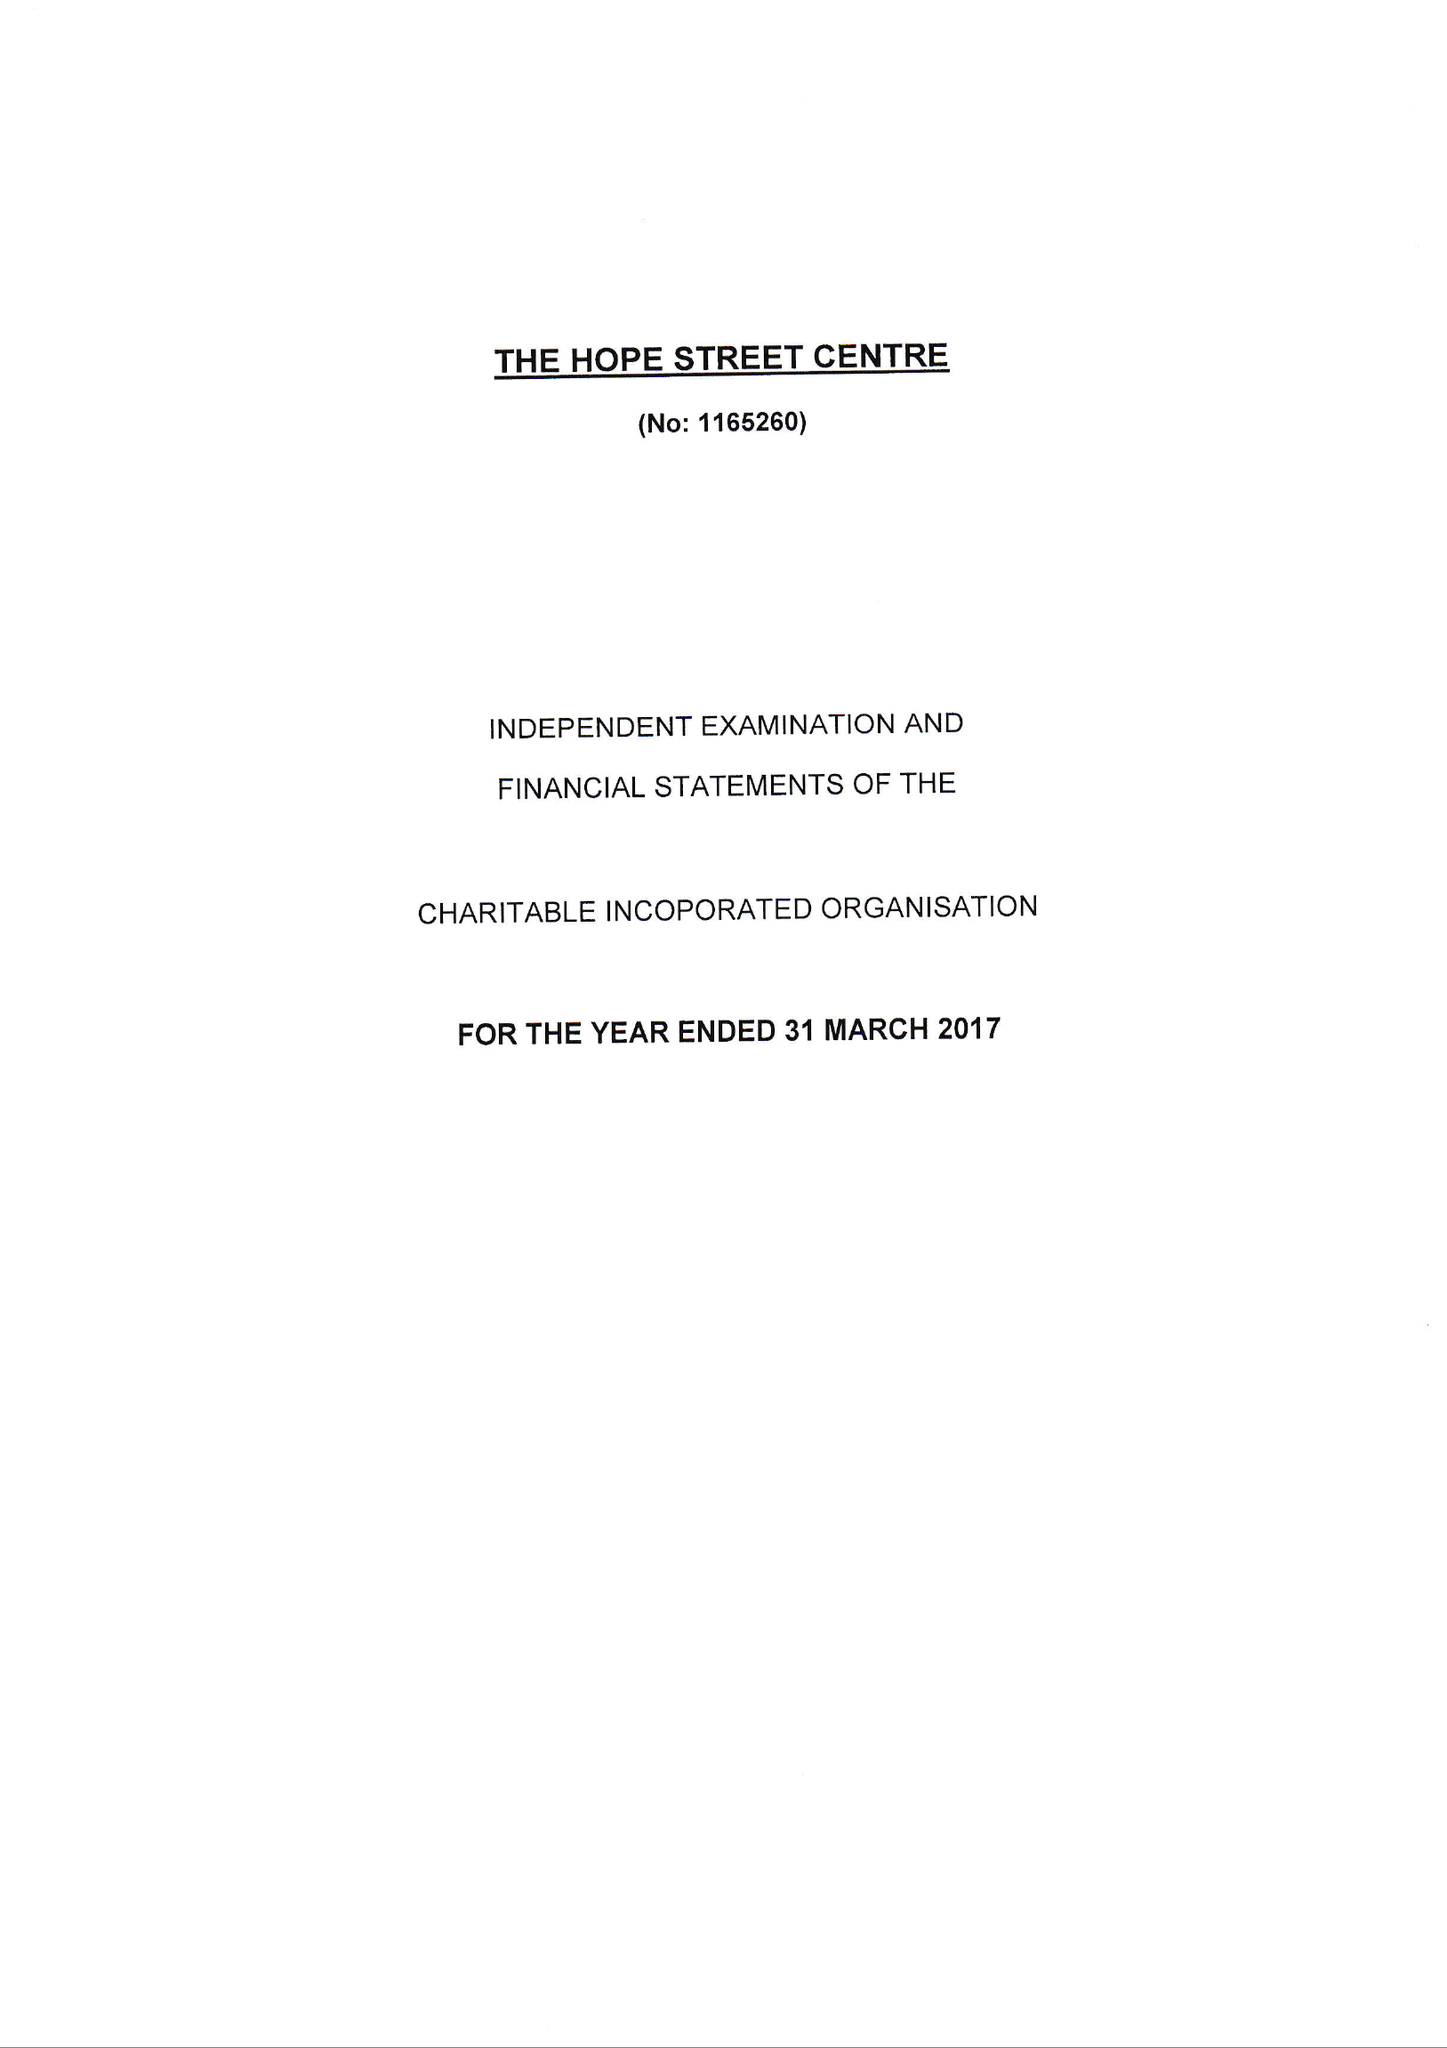What is the value for the address__street_line?
Answer the question using a single word or phrase. None 